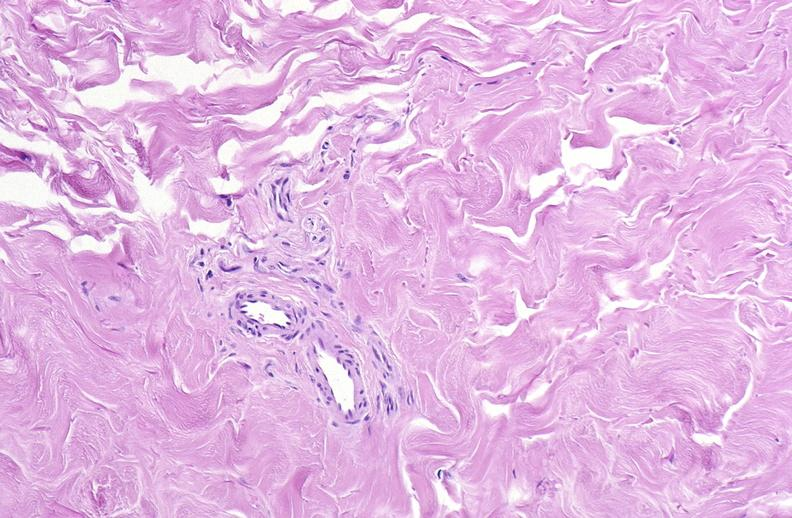does this image show scleroderma?
Answer the question using a single word or phrase. Yes 